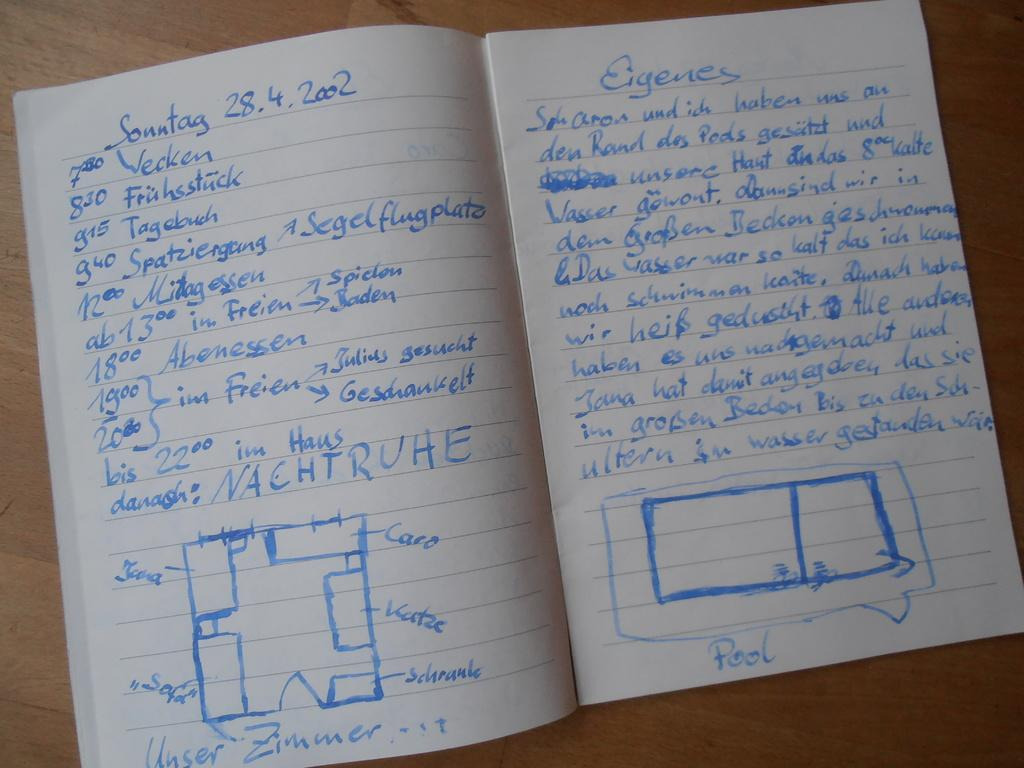What object can be seen in the image? There is a book in the image. What is inside the book? The book has text in it. What type of surface is visible in the image? The wooden surface is present in the image. How many ants are crawling on the book in the image? There are no ants present in the image; only the book and wooden surface are visible. 